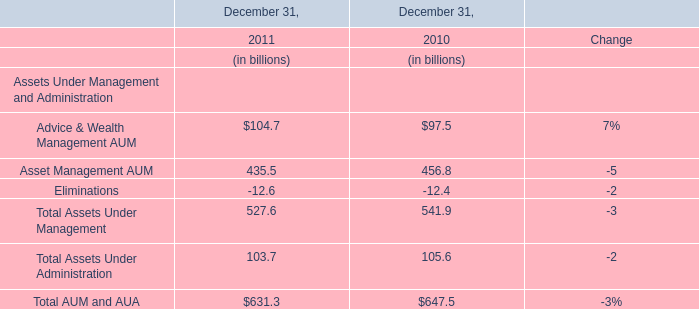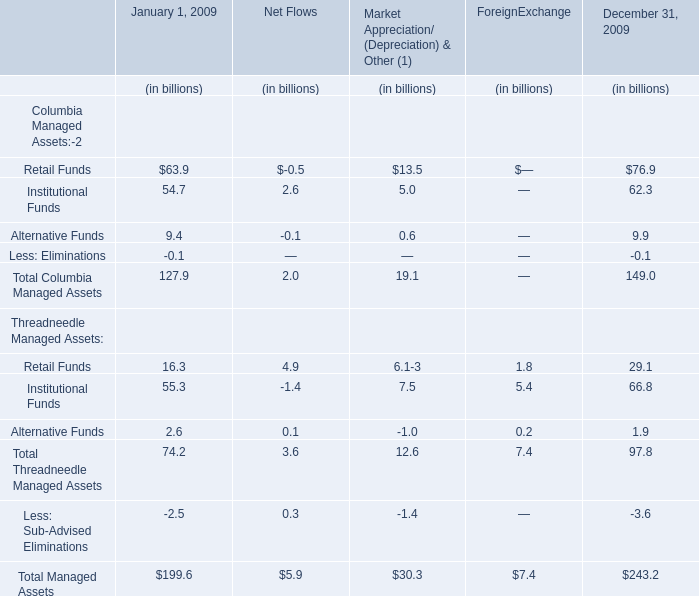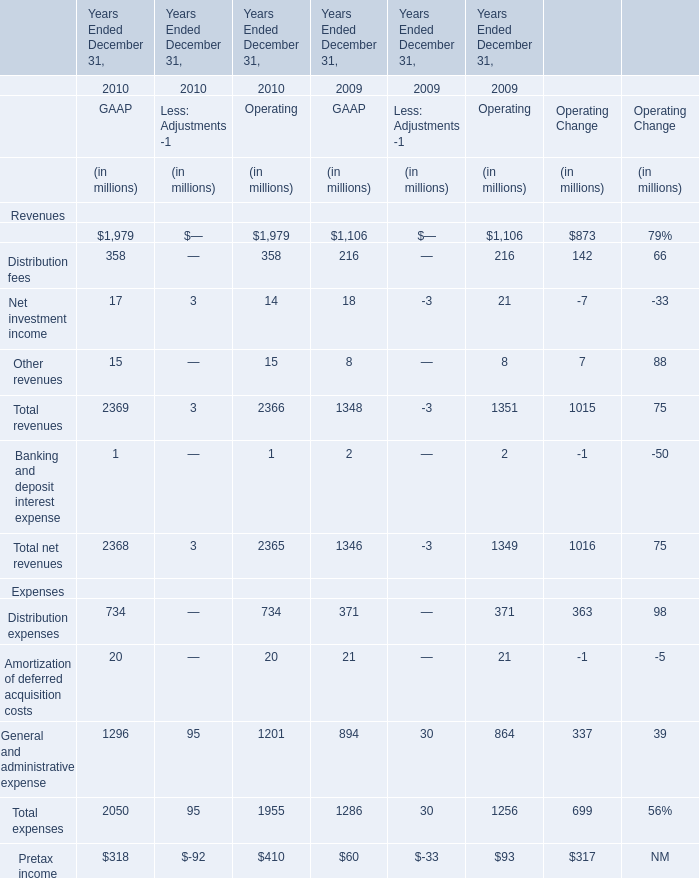What's the total amount of Columbia Managed Assets Funds in 2009? 
Computations: (((127.9 + 2.0) + 19.1) + 149.0)
Answer: 298.0. 